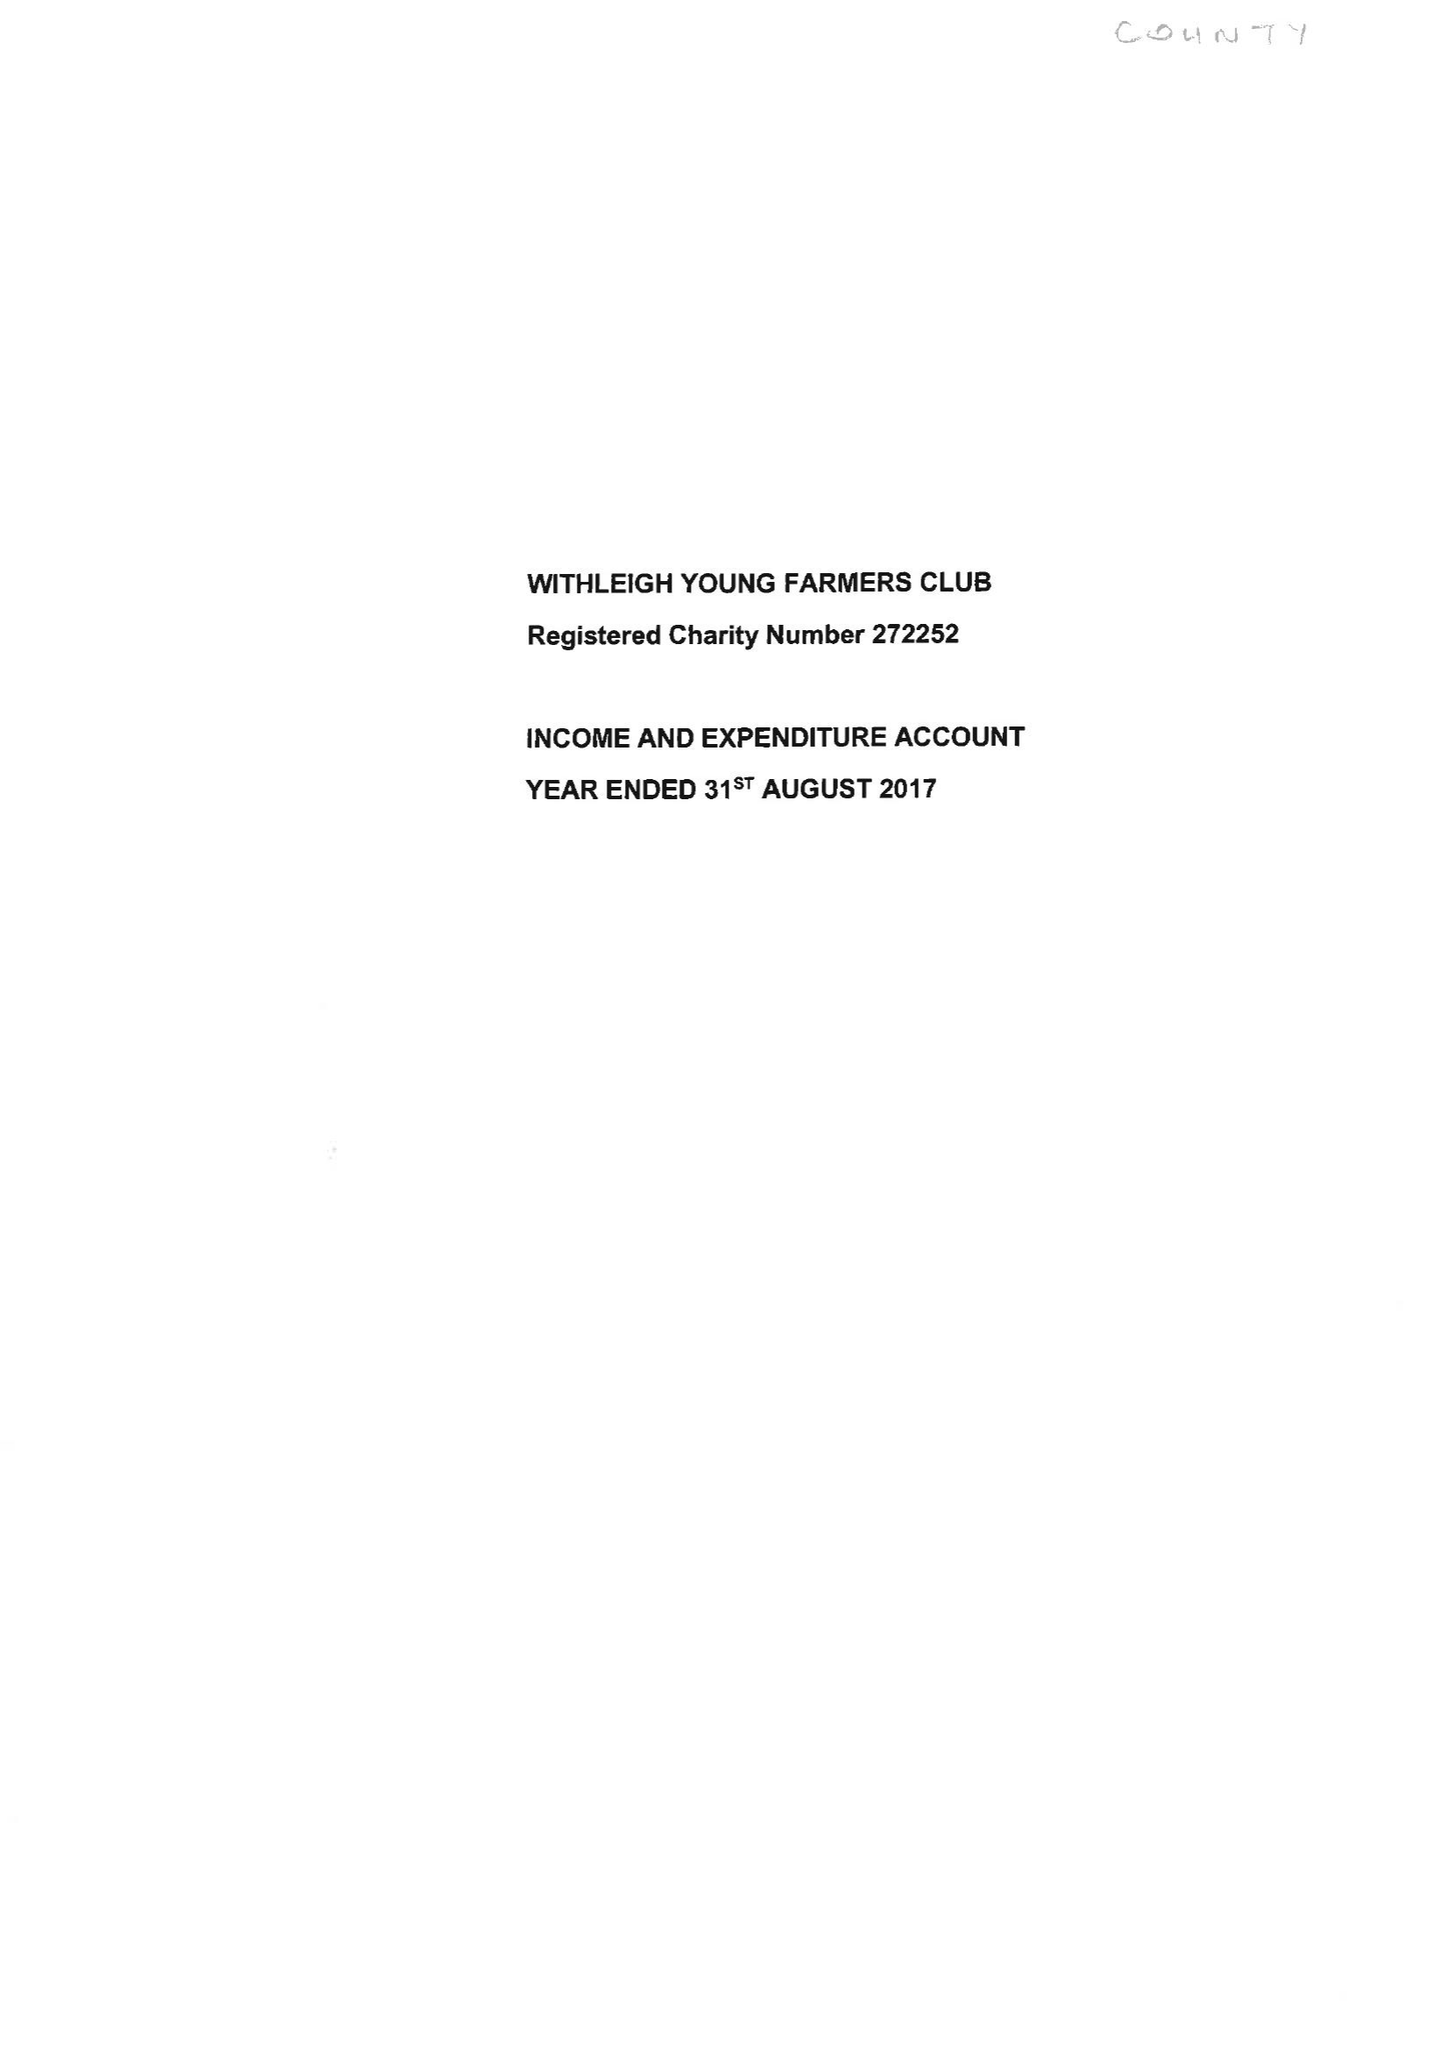What is the value for the charity_number?
Answer the question using a single word or phrase. 272252 